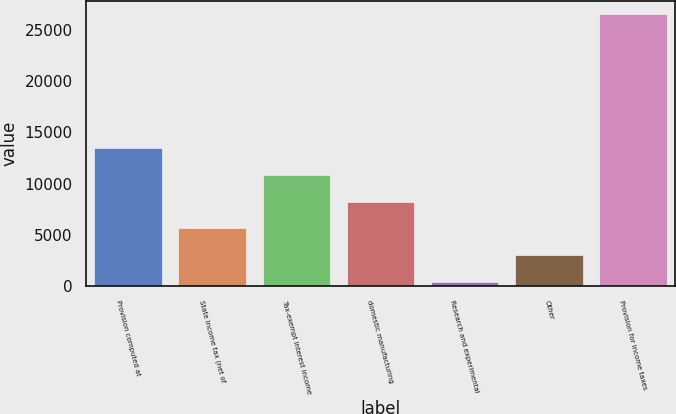Convert chart to OTSL. <chart><loc_0><loc_0><loc_500><loc_500><bar_chart><fcel>Provision computed at<fcel>State income tax (net of<fcel>Tax-exempt interest income<fcel>domestic manufacturing<fcel>Research and experimental<fcel>Other<fcel>Provision for income taxes<nl><fcel>13454<fcel>5621.6<fcel>10843.2<fcel>8232.4<fcel>400<fcel>3010.8<fcel>26508<nl></chart> 